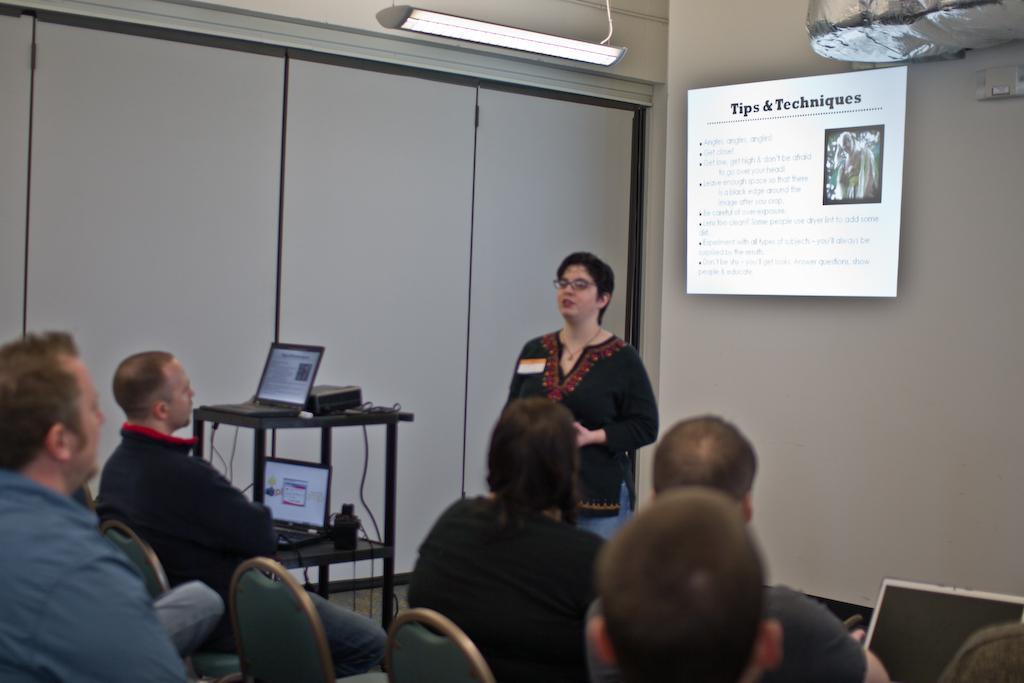Please provide a concise description of this image. In this picture there are several people sitting on the chairs and a lady opposite to them is explaining them. To the left side of the image we find electronic gadgets placed on top of a table and in the background there is a LCD projector. 